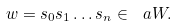<formula> <loc_0><loc_0><loc_500><loc_500>w = s _ { 0 } s _ { 1 } \dots s _ { n } \in \ a W .</formula> 